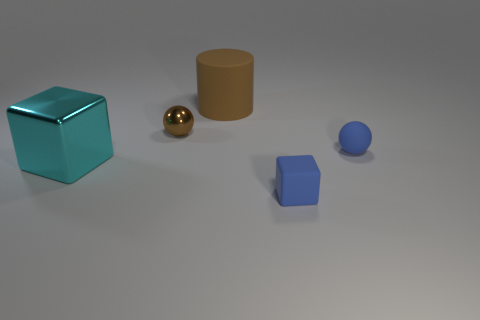Subtract all blue cubes. How many cubes are left? 1 Subtract 2 cubes. How many cubes are left? 0 Add 5 tiny rubber balls. How many tiny rubber balls exist? 6 Add 2 blue metal cylinders. How many objects exist? 7 Subtract 0 blue cylinders. How many objects are left? 5 Subtract all balls. How many objects are left? 3 Subtract all yellow blocks. Subtract all yellow cylinders. How many blocks are left? 2 Subtract all gray cylinders. How many blue balls are left? 1 Subtract all big cyan rubber cylinders. Subtract all blue matte spheres. How many objects are left? 4 Add 2 blue rubber balls. How many blue rubber balls are left? 3 